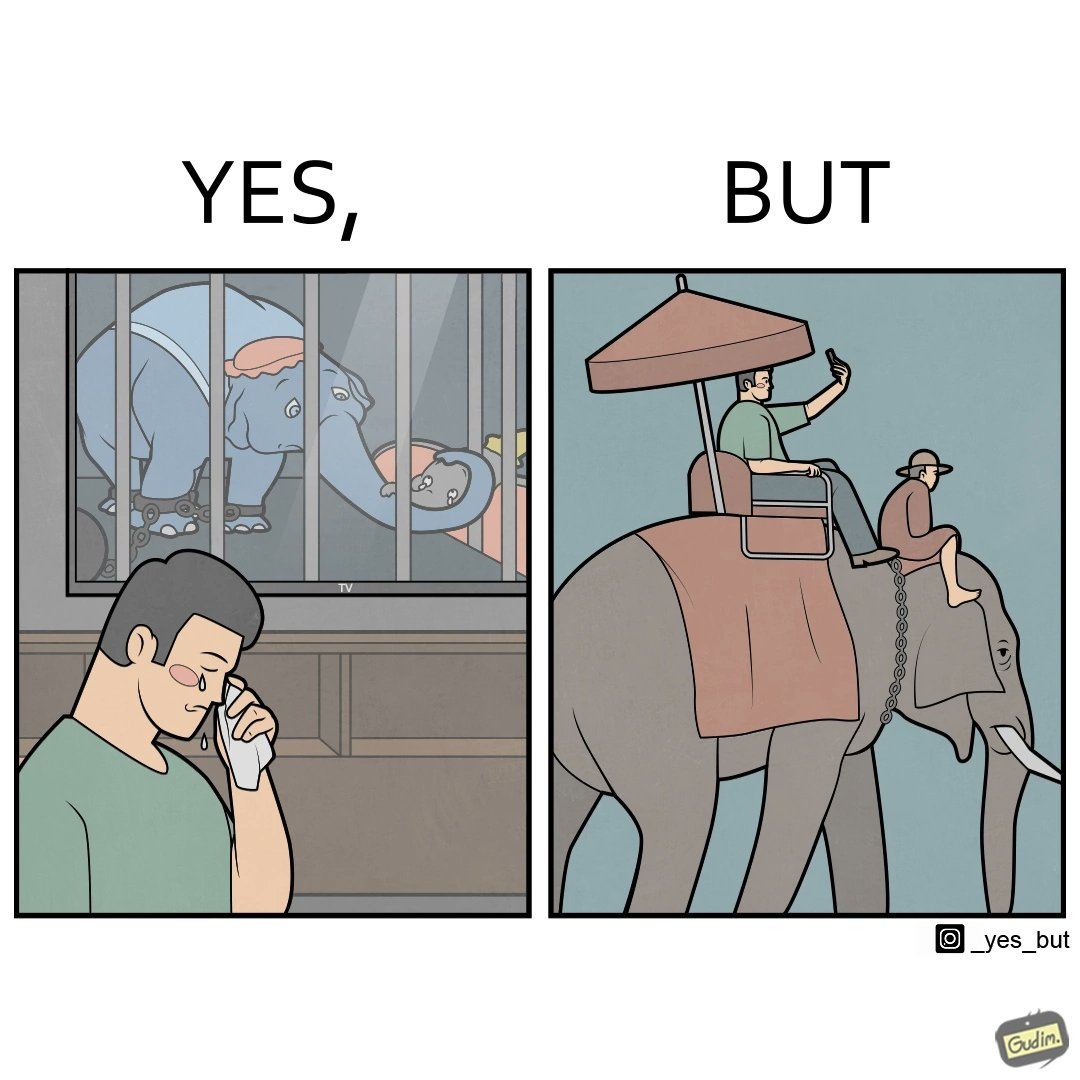Is there satirical content in this image? Yes, this image is satirical. 